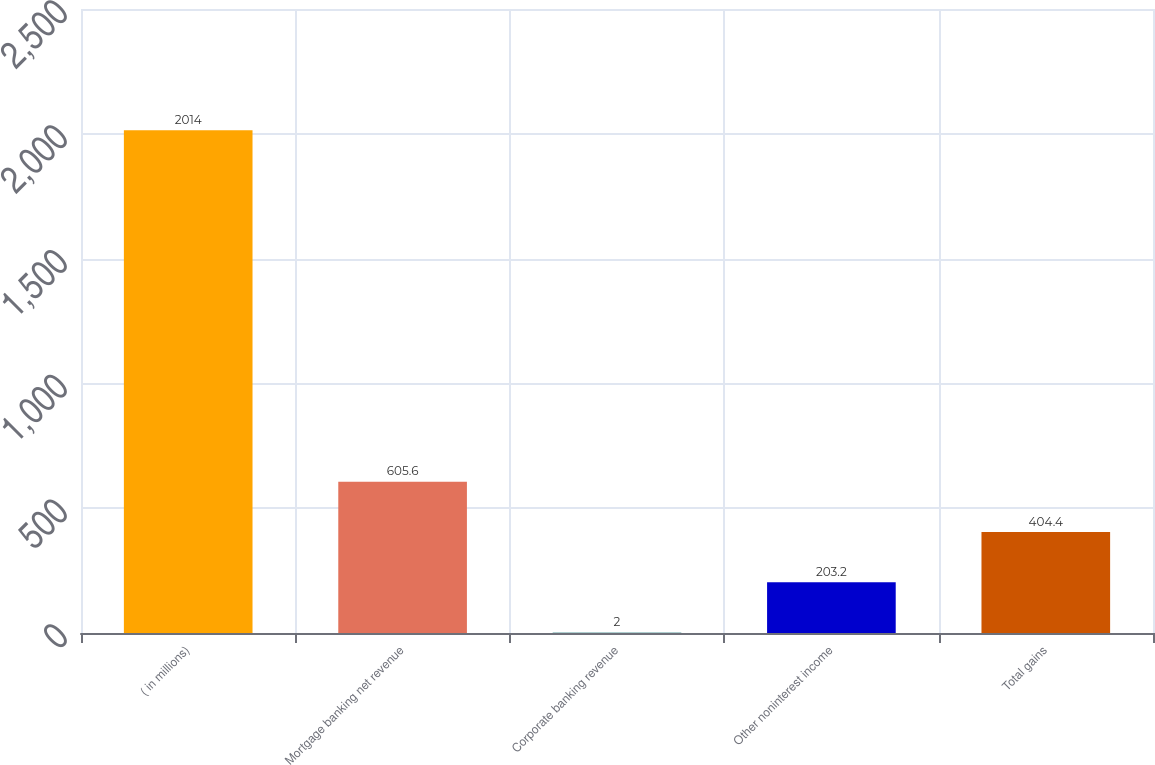Convert chart. <chart><loc_0><loc_0><loc_500><loc_500><bar_chart><fcel>( in millions)<fcel>Mortgage banking net revenue<fcel>Corporate banking revenue<fcel>Other noninterest income<fcel>Total gains<nl><fcel>2014<fcel>605.6<fcel>2<fcel>203.2<fcel>404.4<nl></chart> 